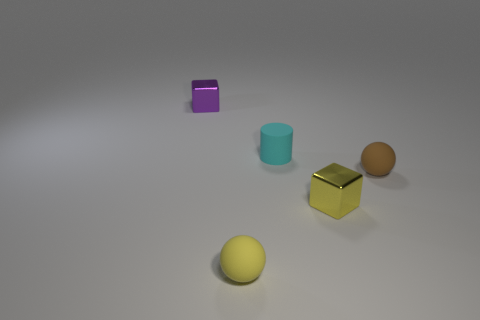What is the material of the other tiny object that is the same shape as the tiny yellow shiny object?
Your answer should be very brief. Metal. Are there any small yellow shiny things in front of the tiny purple shiny cube?
Your answer should be compact. Yes. How many tiny matte things are behind the block that is to the right of the purple object?
Give a very brief answer. 2. The brown object that is the same material as the small yellow sphere is what size?
Your answer should be very brief. Small. The cyan rubber object is what size?
Keep it short and to the point. Small. Is the material of the cylinder the same as the yellow sphere?
Offer a very short reply. Yes. How many cubes are tiny metal objects or purple objects?
Ensure brevity in your answer.  2. There is a tiny block to the left of the small cube in front of the brown rubber thing; what is its color?
Keep it short and to the point. Purple. There is a metal object that is behind the ball that is right of the tiny yellow matte ball; how many small cubes are behind it?
Provide a succinct answer. 0. There is a small metallic thing that is behind the cyan rubber thing; does it have the same shape as the metal object that is in front of the purple object?
Offer a very short reply. Yes. 